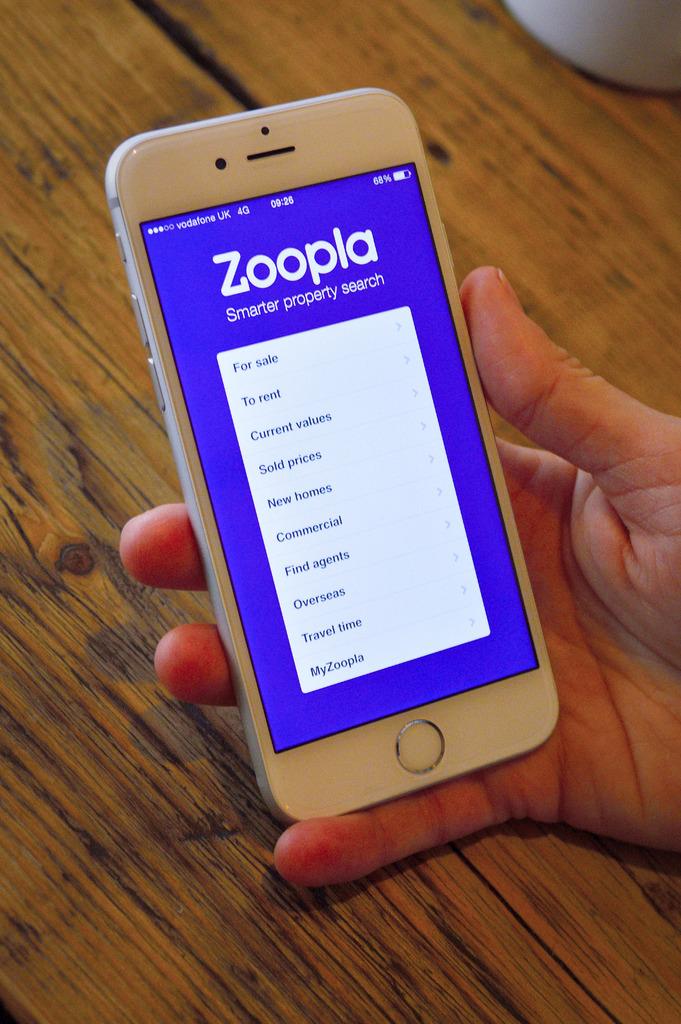What is the app on the phone?
Provide a short and direct response. Zoopla. What network provider is this phone on?
Offer a very short reply. Zoopla. 